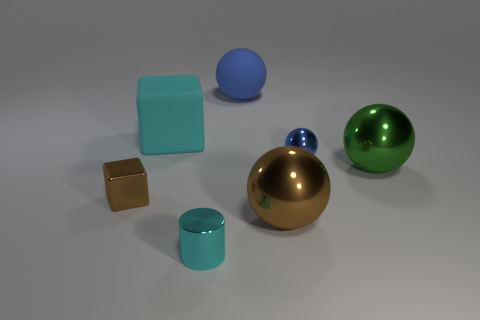Subtract all small spheres. How many spheres are left? 3 Add 3 big cyan cubes. How many objects exist? 10 Subtract 4 spheres. How many spheres are left? 0 Subtract all brown cubes. How many cubes are left? 1 Add 6 small blue balls. How many small blue balls exist? 7 Subtract 1 cyan cubes. How many objects are left? 6 Subtract all cubes. How many objects are left? 5 Subtract all red cylinders. Subtract all cyan spheres. How many cylinders are left? 1 Subtract all red cylinders. How many cyan cubes are left? 1 Subtract all gray blocks. Subtract all cyan cylinders. How many objects are left? 6 